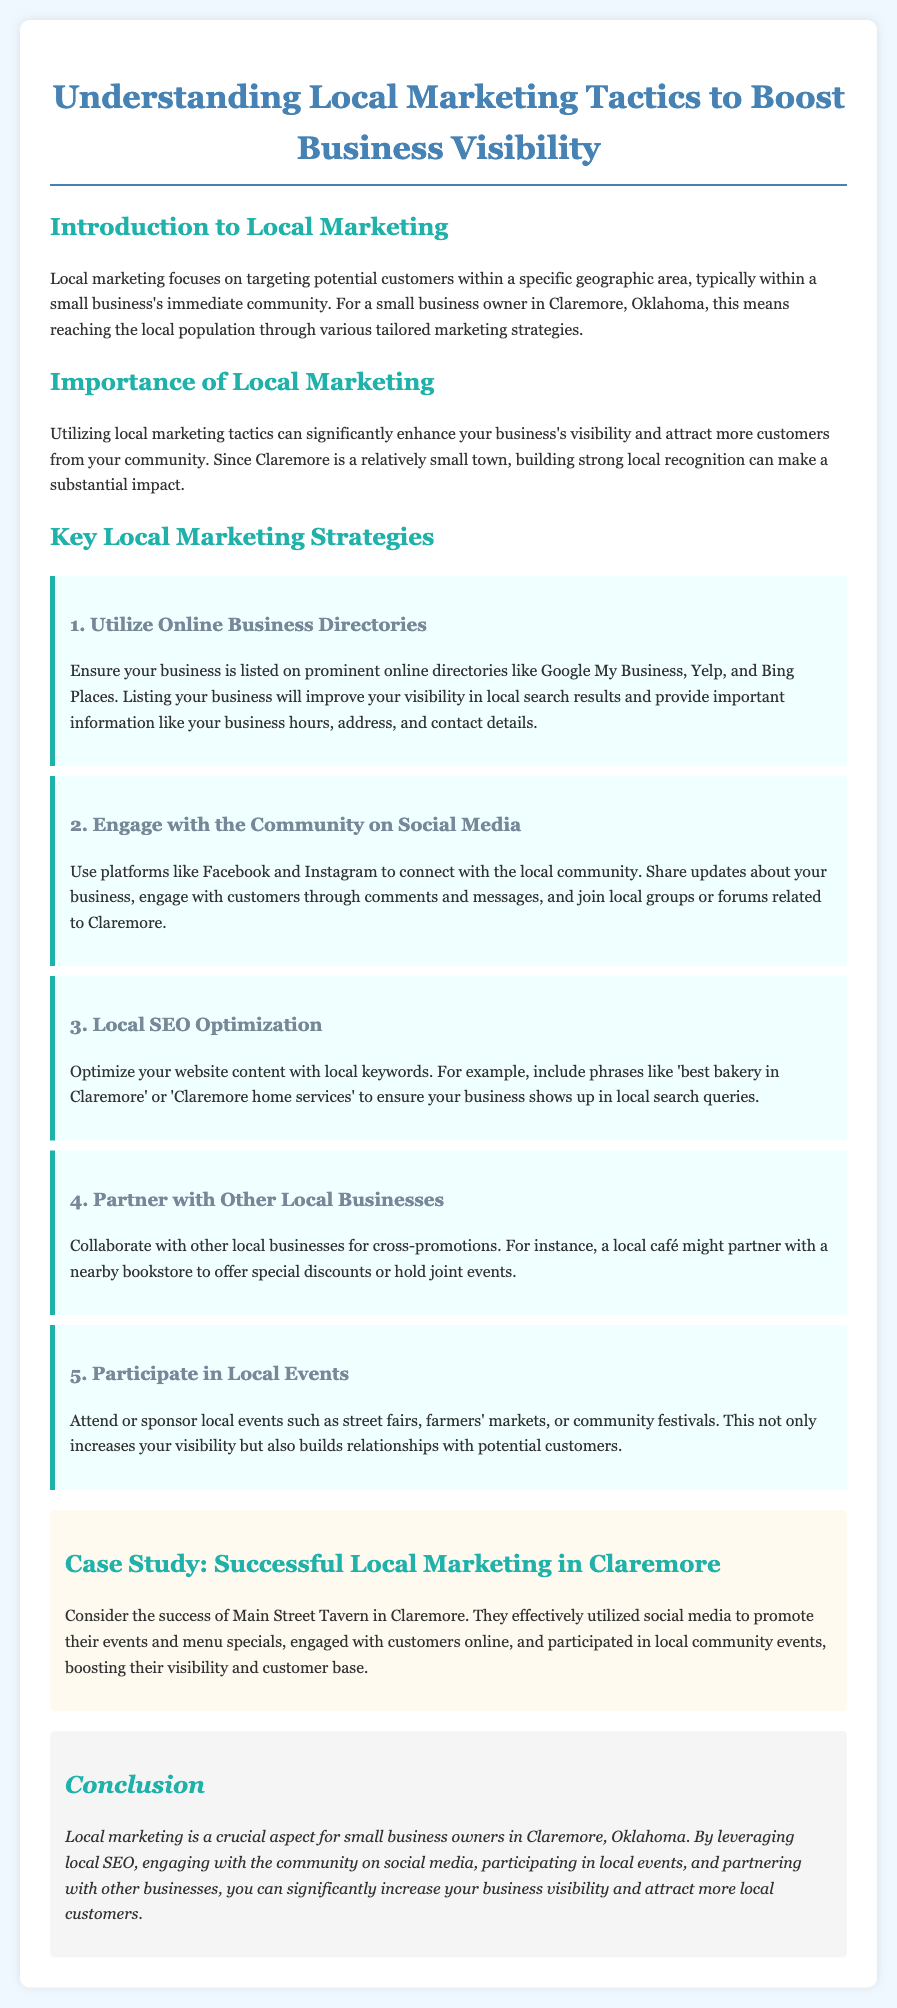What is the main focus of local marketing? The document states that local marketing focuses on targeting potential customers within a specific geographic area.
Answer: Targeting potential customers within a specific geographic area What is one benefit of local marketing mentioned? The importance of local marketing includes enhancing business visibility and attracting more customers.
Answer: Enhancing business visibility Name one online business directory suggested in the document. The document mentions Google My Business as an important online business directory.
Answer: Google My Business What is a key strategy for engaging with the community? The document suggests using social media platforms to connect with the local community.
Answer: Using social media platforms What is an example of a local marketing activity mentioned? Participating in local events such as street fairs is one of the activities mentioned in the document.
Answer: Participating in local events What type of optimization is discussed for websites? The document discusses local SEO optimization for website content.
Answer: Local SEO optimization Which local business is highlighted as a case study? The case study features Main Street Tavern in Claremore.
Answer: Main Street Tavern How can small businesses increase visibility according to the conclusion? By leveraging local SEO and community engagement, small businesses can increase visibility according to the conclusion.
Answer: By leveraging local SEO and community engagement 